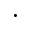Convert formula to latex. <formula><loc_0><loc_0><loc_500><loc_500>\cdot</formula> 